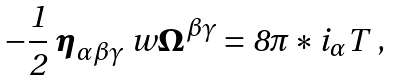<formula> <loc_0><loc_0><loc_500><loc_500>- \frac { 1 } { 2 } \ { \boldsymbol \eta } _ { \alpha \beta \gamma } \ w { \boldsymbol \Omega } ^ { \beta \gamma } = 8 \pi * i _ { \alpha } { T } \ ,</formula> 